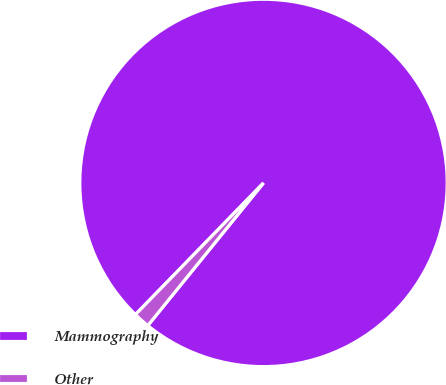Convert chart to OTSL. <chart><loc_0><loc_0><loc_500><loc_500><pie_chart><fcel>Mammography<fcel>Other<nl><fcel>98.57%<fcel>1.43%<nl></chart> 